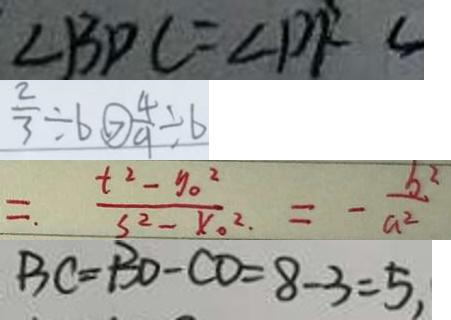<formula> <loc_0><loc_0><loc_500><loc_500>\angle B D C = \angle D F C 
 \frac { 2 } { 3 } \div 6 > \frac { 4 } { 9 } \div 6 
 = \frac { t ^ { 2 } - y _ { 0 } ^ { 2 } } { 3 ^ { 2 } - x _ { 0 } ^ { 2 } } = - \frac { b ^ { 2 } } { a ^ { 2 } } 
 B C = B D - C O = 8 - 3 = 5 ,</formula> 